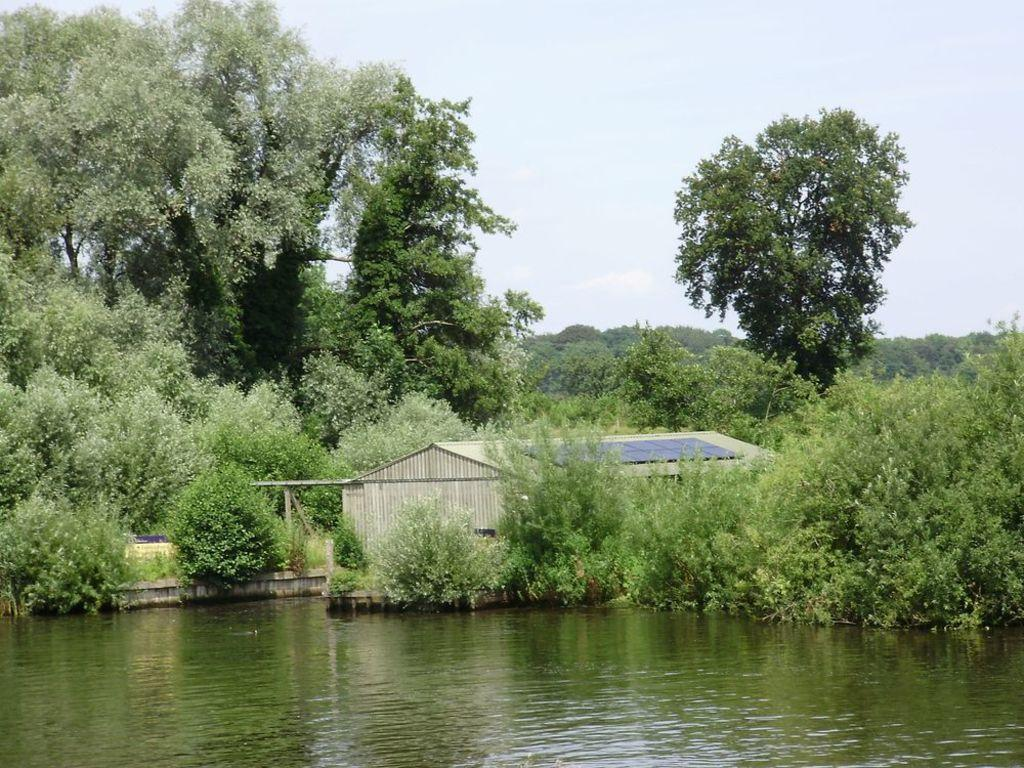What is visible in the image? Water is visible in the image. What can be seen in the background of the image? There is a house and green trees in the background of the image. What is the color of the sky in the image? The sky is white in color. What type of fear can be seen on the finger of the person in the image? There is no person present in the image, and therefore no fear or fingers can be observed. 